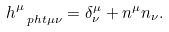<formula> <loc_0><loc_0><loc_500><loc_500>h ^ { \mu } _ { \ p h t { \mu } \nu } = \delta ^ { \mu } _ { \nu } + n ^ { \mu } n _ { \nu } .</formula> 